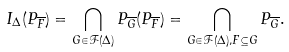<formula> <loc_0><loc_0><loc_500><loc_500>I _ { \Delta } ( P _ { \overline { F } } ) = \bigcap _ { G \in \mathcal { F } ( \Delta ) } P _ { \overline { G } } ( P _ { \overline { F } } ) = \bigcap _ { G \in \mathcal { F } ( \Delta ) , F \subseteq G } P _ { \overline { G } } .</formula> 